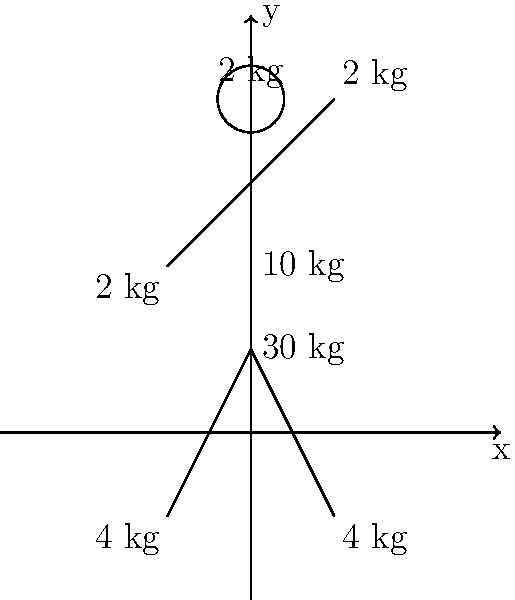A gymnast is holding a pose as shown in the figure. Given the masses of different body parts, calculate the x-coordinate of the center of gravity for this pose. Round your answer to two decimal places. To find the x-coordinate of the center of gravity, we need to use the weighted average formula:

$$ x_{cg} = \frac{\sum m_i x_i}{\sum m_i} $$

Where $m_i$ is the mass of each body part and $x_i$ is its x-coordinate.

Let's break it down step-by-step:

1) Identify the masses and x-coordinates:
   - Head: 2 kg at x = 0
   - Torso: 10 kg at x = 0
   - Hips: 30 kg at x = 0
   - Left hand: 2 kg at x = -0.5
   - Right hand: 2 kg at x = 0.5
   - Left foot: 4 kg at x = -0.5
   - Right foot: 4 kg at x = 0.5

2) Calculate $\sum m_i x_i$:
   $$(2 * 0) + (10 * 0) + (30 * 0) + (2 * -0.5) + (2 * 0.5) + (4 * -0.5) + (4 * 0.5) = 0$$

3) Calculate $\sum m_i$:
   $$2 + 10 + 30 + 2 + 2 + 4 + 4 = 54 \text{ kg}$$

4) Apply the formula:
   $$ x_{cg} = \frac{0}{54} = 0 $$

5) Round to two decimal places: 0.00

The x-coordinate of the center of gravity is at the vertical axis of symmetry, which makes sense given the balanced pose of the gymnast.
Answer: 0.00 